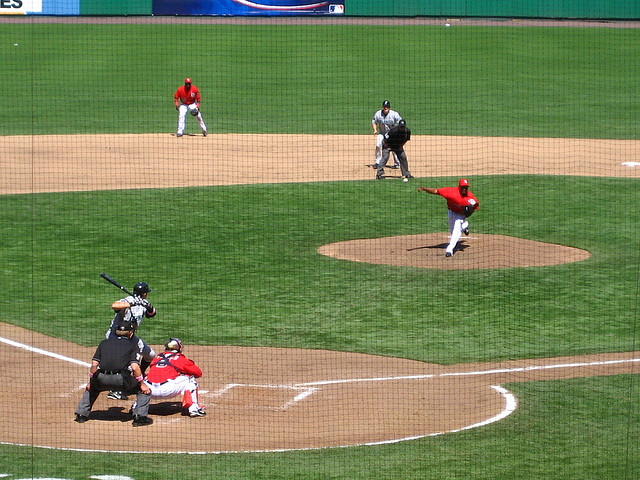Can you describe the setting of this image? Certainly, the image appears to be taken in a stadium during a clear day, which can be inferred by the shadows on the field, suggesting it's either late morning or early afternoon. The infield has been neatly raked, and you can see the distinct outline of the diamond against the well-maintained grass. The stands in the background, although not clearly visible, suggest the presence of a spectating crowd.  What can you say about the teams playing? While specific team names are not identifiable without logos or clear images of their uniforms, we can see distinctively colored jerseys. One team is wearing red uniforms, which is typical for many baseball teams, while the opposing team's colors are not visible in this shot. Their gear and posture suggest they're professionals, given the formality of their attire and the way they hold themselves in the field. 